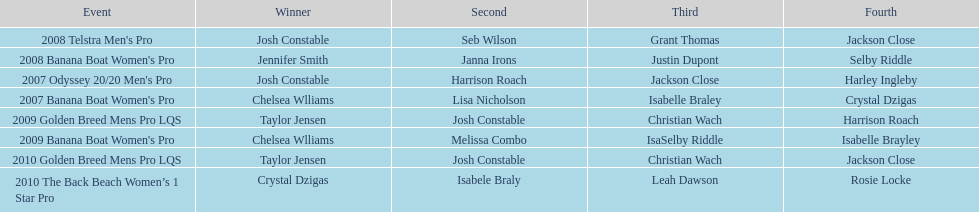How many victories did josh constable have post-2007? 1. 